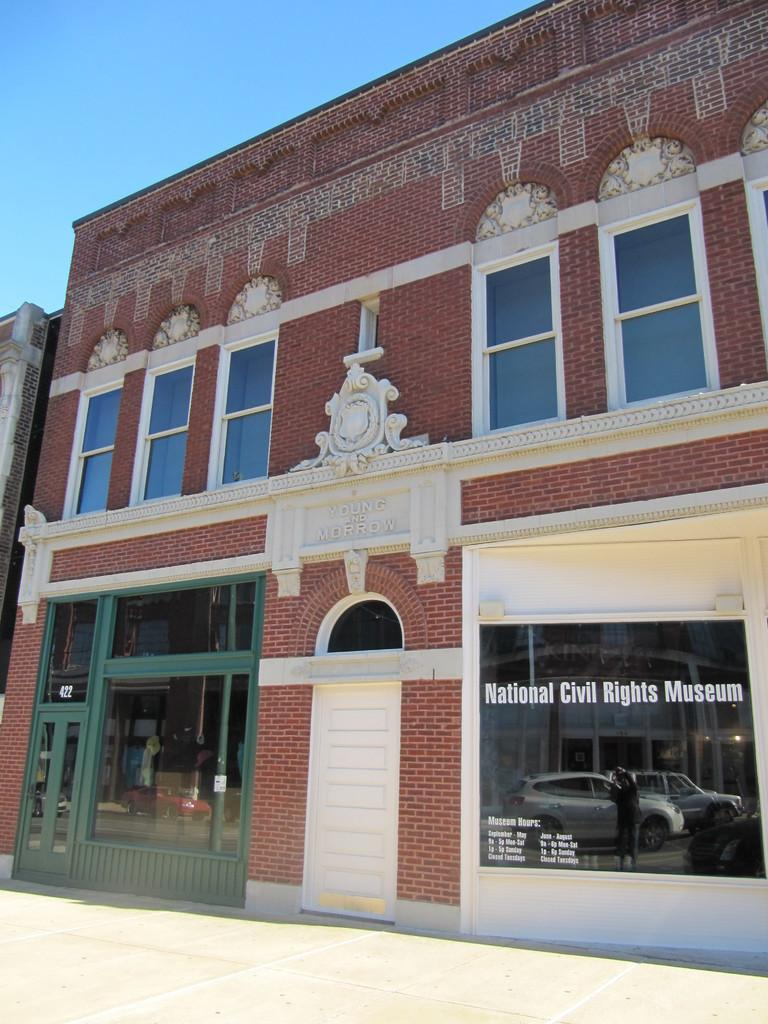What type of structures can be seen in the image? There are buildings in the image. Are there any decorative elements on the buildings? Yes, there is a sculpture on one of the buildings. What can be seen in the background of the image? The sky is visible in the background of the image. What is reflected in the glass of the building? There is a reflection of cars and a person in the glass. How many passengers are in the van that is parked in front of the building? There is no van present in the image, so it is not possible to determine the number of passengers. 